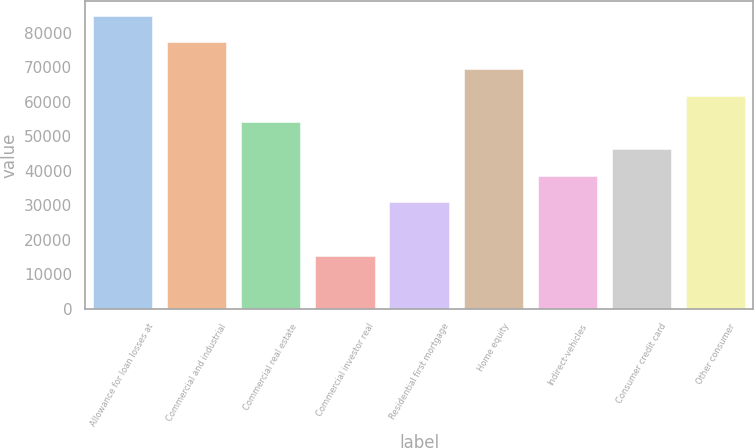Convert chart. <chart><loc_0><loc_0><loc_500><loc_500><bar_chart><fcel>Allowance for loan losses at<fcel>Commercial and industrial<fcel>Commercial real estate<fcel>Commercial investor real<fcel>Residential first mortgage<fcel>Home equity<fcel>Indirect-vehicles<fcel>Consumer credit card<fcel>Other consumer<nl><fcel>85037.7<fcel>77307<fcel>54115<fcel>15461.7<fcel>30923<fcel>69576.3<fcel>38653.7<fcel>46384.4<fcel>61845.7<nl></chart> 